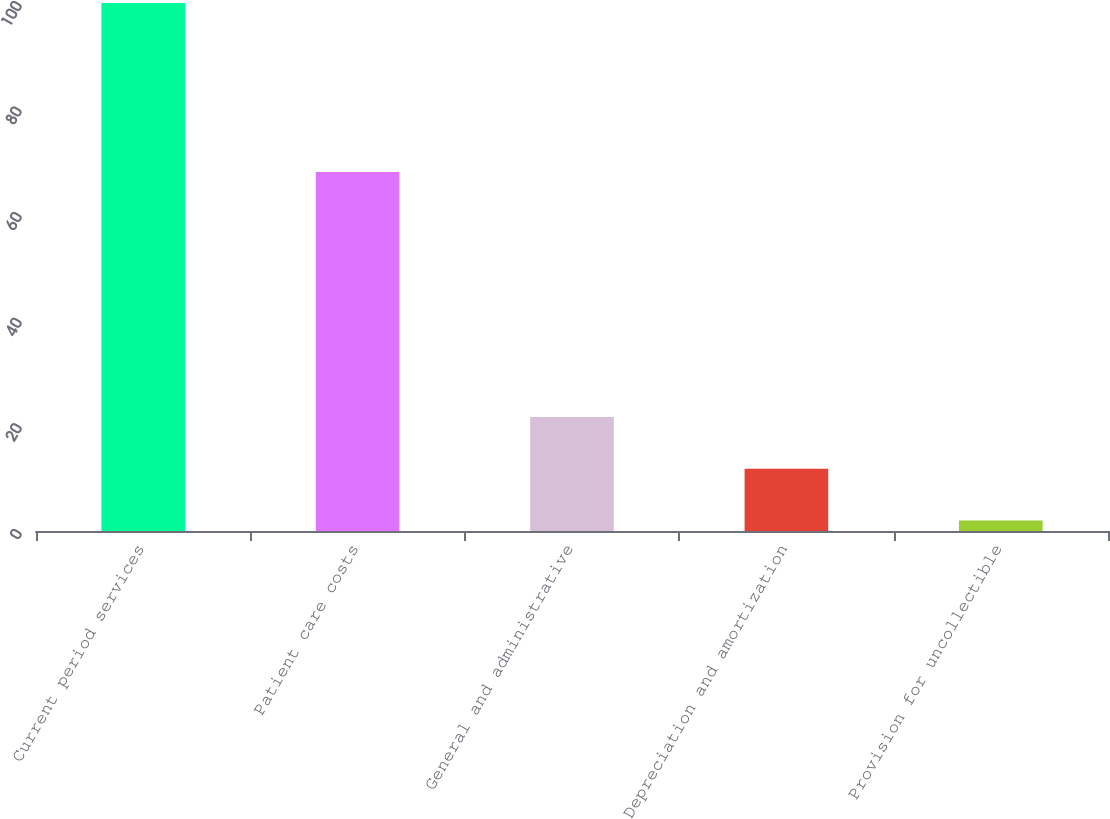<chart> <loc_0><loc_0><loc_500><loc_500><bar_chart><fcel>Current period services<fcel>Patient care costs<fcel>General and administrative<fcel>Depreciation and amortization<fcel>Provision for uncollectible<nl><fcel>100<fcel>68<fcel>21.6<fcel>11.8<fcel>2<nl></chart> 